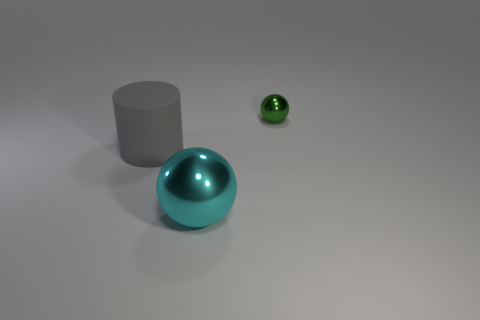What is the shape of the thing that is both in front of the green object and on the right side of the gray object?
Offer a very short reply. Sphere. How many tiny green metallic balls are there?
Your answer should be compact. 1. There is a cyan metal object that is the same shape as the green object; what size is it?
Ensure brevity in your answer.  Large. There is a thing that is behind the rubber object; is it the same shape as the cyan metal thing?
Offer a very short reply. Yes. There is a ball in front of the tiny object; what is its color?
Your answer should be very brief. Cyan. What number of other things are the same size as the gray object?
Keep it short and to the point. 1. Are there any other things that are the same shape as the gray matte thing?
Ensure brevity in your answer.  No. Are there the same number of cyan balls that are in front of the small metallic ball and tiny gray metal cylinders?
Offer a terse response. No. What number of small purple things have the same material as the large cyan object?
Your response must be concise. 0. There is a small sphere that is made of the same material as the big cyan thing; what is its color?
Your response must be concise. Green. 